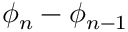Convert formula to latex. <formula><loc_0><loc_0><loc_500><loc_500>\phi _ { n } - \phi _ { n - 1 }</formula> 